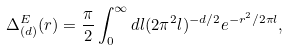<formula> <loc_0><loc_0><loc_500><loc_500>\Delta _ { ( d ) } ^ { E } ( r ) = \frac { \pi } { 2 } \int _ { 0 } ^ { \infty } d l ( 2 \pi ^ { 2 } l ) ^ { - d / 2 } e ^ { - r ^ { 2 } / 2 \pi l } ,</formula> 